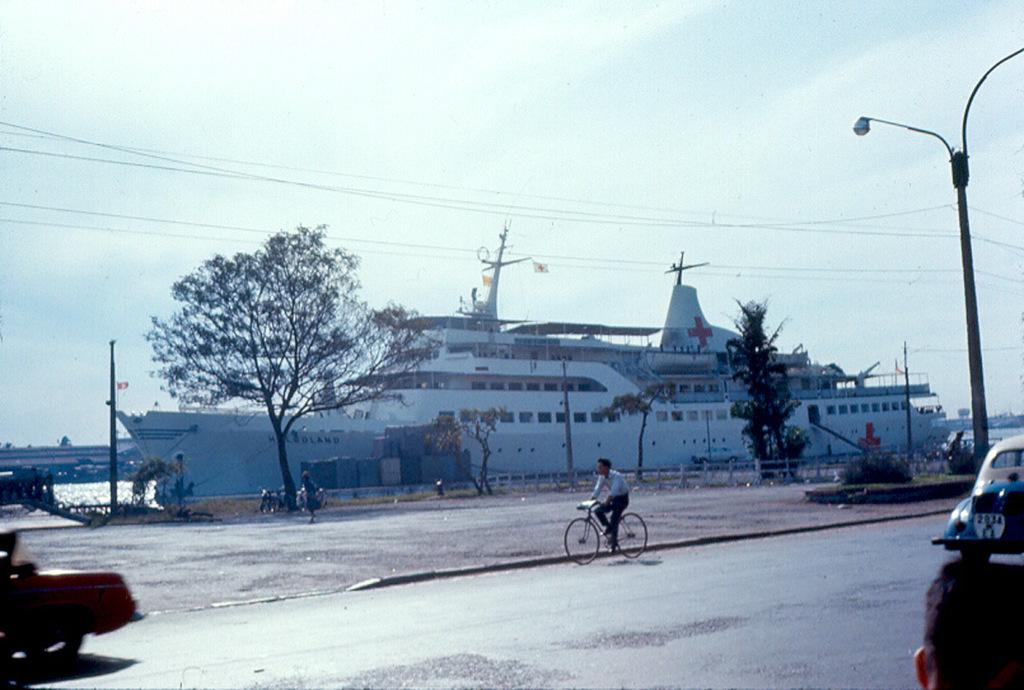What is the main subject of the image? The main subject of the image is a ship. What can be seen in the background of the image? There is water, the sky, clouds, and trees visible in the background of the image. What type of infrastructure is present in the image? Cables, street poles, and street lights are present in the image. What type of transportation is visible in the image? Motor vehicles and a person riding a bicycle are present in the image. How many fairies are flying around the ship in the image? There are no fairies present in the image; it features a ship, water, sky, clouds, trees, cables, street poles, street lights, motor vehicles, and a person riding a bicycle. 